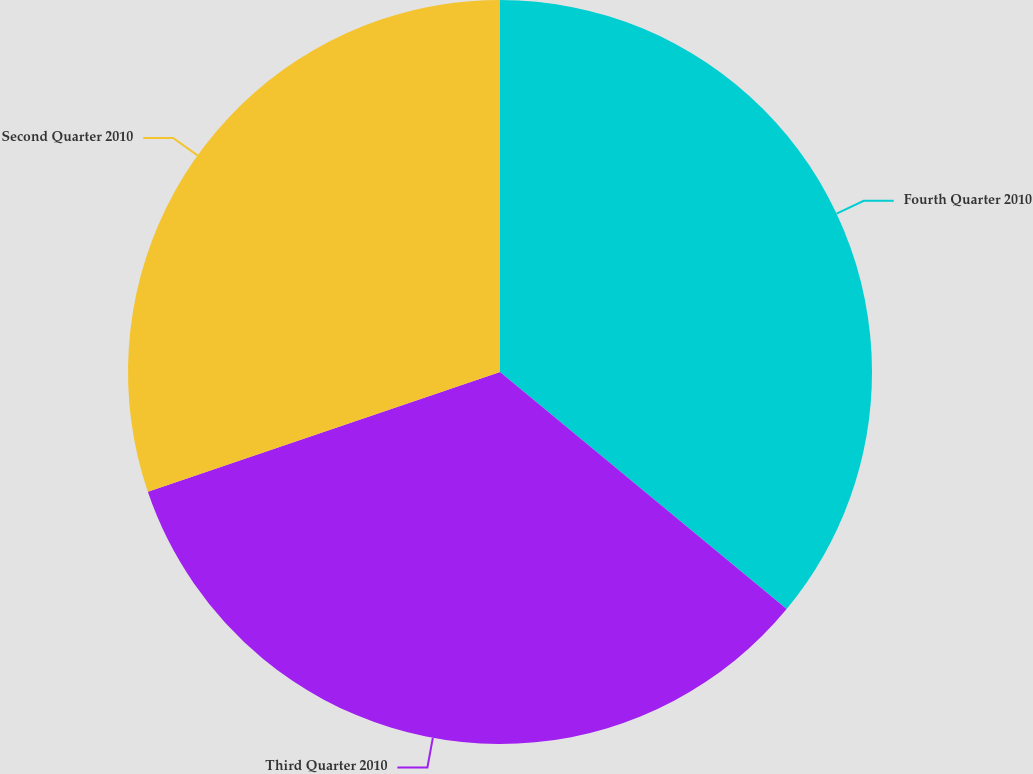Convert chart. <chart><loc_0><loc_0><loc_500><loc_500><pie_chart><fcel>Fourth Quarter 2010<fcel>Third Quarter 2010<fcel>Second Quarter 2010<nl><fcel>36.0%<fcel>33.78%<fcel>30.22%<nl></chart> 